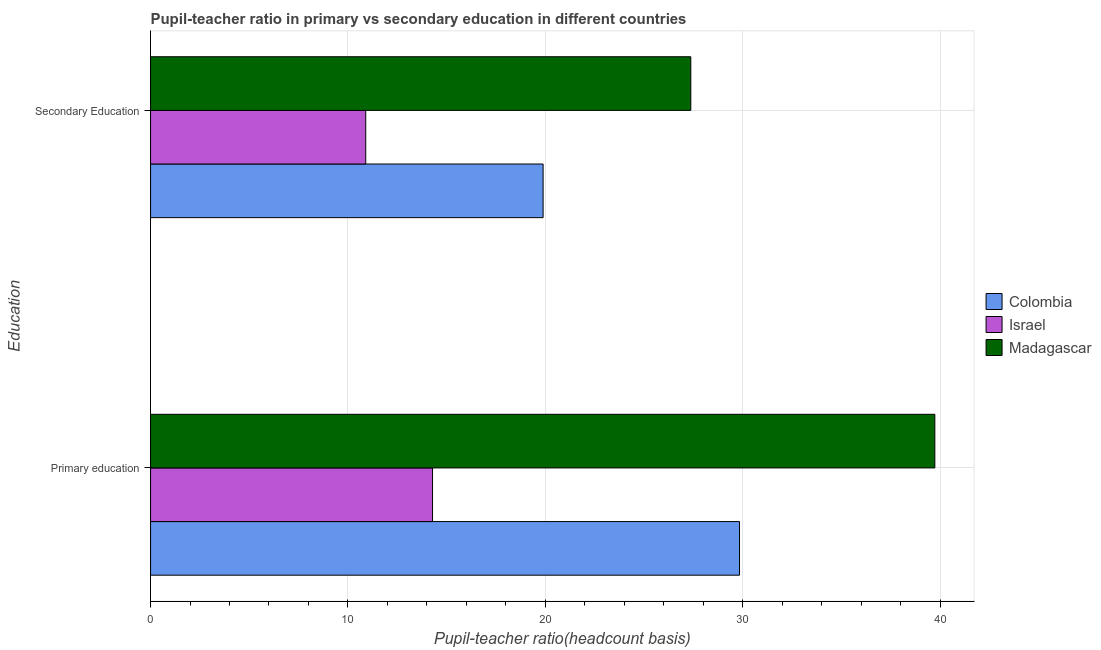How many groups of bars are there?
Your response must be concise. 2. Are the number of bars per tick equal to the number of legend labels?
Ensure brevity in your answer.  Yes. Are the number of bars on each tick of the Y-axis equal?
Keep it short and to the point. Yes. How many bars are there on the 2nd tick from the top?
Keep it short and to the point. 3. How many bars are there on the 1st tick from the bottom?
Offer a very short reply. 3. What is the label of the 1st group of bars from the top?
Provide a succinct answer. Secondary Education. What is the pupil-teacher ratio in primary education in Israel?
Provide a short and direct response. 14.29. Across all countries, what is the maximum pupil-teacher ratio in primary education?
Your response must be concise. 39.74. Across all countries, what is the minimum pupil-teacher ratio in primary education?
Keep it short and to the point. 14.29. In which country was the pupil-teacher ratio in primary education maximum?
Your response must be concise. Madagascar. In which country was the pupil-teacher ratio in primary education minimum?
Offer a terse response. Israel. What is the total pupil teacher ratio on secondary education in the graph?
Make the answer very short. 58.16. What is the difference between the pupil teacher ratio on secondary education in Madagascar and that in Colombia?
Offer a terse response. 7.48. What is the difference between the pupil-teacher ratio in primary education in Colombia and the pupil teacher ratio on secondary education in Madagascar?
Ensure brevity in your answer.  2.47. What is the average pupil-teacher ratio in primary education per country?
Provide a succinct answer. 27.95. What is the difference between the pupil-teacher ratio in primary education and pupil teacher ratio on secondary education in Israel?
Give a very brief answer. 3.38. In how many countries, is the pupil-teacher ratio in primary education greater than 16 ?
Provide a succinct answer. 2. What is the ratio of the pupil-teacher ratio in primary education in Colombia to that in Israel?
Offer a very short reply. 2.09. Is the pupil teacher ratio on secondary education in Israel less than that in Colombia?
Keep it short and to the point. Yes. In how many countries, is the pupil-teacher ratio in primary education greater than the average pupil-teacher ratio in primary education taken over all countries?
Give a very brief answer. 2. What does the 1st bar from the top in Secondary Education represents?
Make the answer very short. Madagascar. Are all the bars in the graph horizontal?
Provide a short and direct response. Yes. How many countries are there in the graph?
Offer a very short reply. 3. What is the difference between two consecutive major ticks on the X-axis?
Offer a very short reply. 10. Does the graph contain grids?
Ensure brevity in your answer.  Yes. How many legend labels are there?
Make the answer very short. 3. What is the title of the graph?
Offer a very short reply. Pupil-teacher ratio in primary vs secondary education in different countries. What is the label or title of the X-axis?
Offer a terse response. Pupil-teacher ratio(headcount basis). What is the label or title of the Y-axis?
Give a very brief answer. Education. What is the Pupil-teacher ratio(headcount basis) in Colombia in Primary education?
Offer a very short reply. 29.84. What is the Pupil-teacher ratio(headcount basis) of Israel in Primary education?
Your answer should be compact. 14.29. What is the Pupil-teacher ratio(headcount basis) of Madagascar in Primary education?
Keep it short and to the point. 39.74. What is the Pupil-teacher ratio(headcount basis) in Colombia in Secondary Education?
Provide a succinct answer. 19.89. What is the Pupil-teacher ratio(headcount basis) in Israel in Secondary Education?
Offer a very short reply. 10.9. What is the Pupil-teacher ratio(headcount basis) in Madagascar in Secondary Education?
Your answer should be compact. 27.37. Across all Education, what is the maximum Pupil-teacher ratio(headcount basis) of Colombia?
Your response must be concise. 29.84. Across all Education, what is the maximum Pupil-teacher ratio(headcount basis) of Israel?
Give a very brief answer. 14.29. Across all Education, what is the maximum Pupil-teacher ratio(headcount basis) in Madagascar?
Your response must be concise. 39.74. Across all Education, what is the minimum Pupil-teacher ratio(headcount basis) in Colombia?
Make the answer very short. 19.89. Across all Education, what is the minimum Pupil-teacher ratio(headcount basis) in Israel?
Give a very brief answer. 10.9. Across all Education, what is the minimum Pupil-teacher ratio(headcount basis) of Madagascar?
Your answer should be compact. 27.37. What is the total Pupil-teacher ratio(headcount basis) in Colombia in the graph?
Give a very brief answer. 49.73. What is the total Pupil-teacher ratio(headcount basis) in Israel in the graph?
Keep it short and to the point. 25.19. What is the total Pupil-teacher ratio(headcount basis) in Madagascar in the graph?
Offer a terse response. 67.11. What is the difference between the Pupil-teacher ratio(headcount basis) in Colombia in Primary education and that in Secondary Education?
Ensure brevity in your answer.  9.95. What is the difference between the Pupil-teacher ratio(headcount basis) in Israel in Primary education and that in Secondary Education?
Offer a terse response. 3.38. What is the difference between the Pupil-teacher ratio(headcount basis) in Madagascar in Primary education and that in Secondary Education?
Offer a terse response. 12.37. What is the difference between the Pupil-teacher ratio(headcount basis) in Colombia in Primary education and the Pupil-teacher ratio(headcount basis) in Israel in Secondary Education?
Your response must be concise. 18.94. What is the difference between the Pupil-teacher ratio(headcount basis) of Colombia in Primary education and the Pupil-teacher ratio(headcount basis) of Madagascar in Secondary Education?
Offer a terse response. 2.47. What is the difference between the Pupil-teacher ratio(headcount basis) of Israel in Primary education and the Pupil-teacher ratio(headcount basis) of Madagascar in Secondary Education?
Make the answer very short. -13.09. What is the average Pupil-teacher ratio(headcount basis) in Colombia per Education?
Offer a very short reply. 24.86. What is the average Pupil-teacher ratio(headcount basis) in Israel per Education?
Give a very brief answer. 12.59. What is the average Pupil-teacher ratio(headcount basis) in Madagascar per Education?
Ensure brevity in your answer.  33.55. What is the difference between the Pupil-teacher ratio(headcount basis) of Colombia and Pupil-teacher ratio(headcount basis) of Israel in Primary education?
Your answer should be compact. 15.55. What is the difference between the Pupil-teacher ratio(headcount basis) in Colombia and Pupil-teacher ratio(headcount basis) in Madagascar in Primary education?
Your answer should be very brief. -9.9. What is the difference between the Pupil-teacher ratio(headcount basis) in Israel and Pupil-teacher ratio(headcount basis) in Madagascar in Primary education?
Your answer should be compact. -25.45. What is the difference between the Pupil-teacher ratio(headcount basis) of Colombia and Pupil-teacher ratio(headcount basis) of Israel in Secondary Education?
Give a very brief answer. 8.99. What is the difference between the Pupil-teacher ratio(headcount basis) of Colombia and Pupil-teacher ratio(headcount basis) of Madagascar in Secondary Education?
Make the answer very short. -7.48. What is the difference between the Pupil-teacher ratio(headcount basis) of Israel and Pupil-teacher ratio(headcount basis) of Madagascar in Secondary Education?
Give a very brief answer. -16.47. What is the ratio of the Pupil-teacher ratio(headcount basis) of Colombia in Primary education to that in Secondary Education?
Keep it short and to the point. 1.5. What is the ratio of the Pupil-teacher ratio(headcount basis) of Israel in Primary education to that in Secondary Education?
Make the answer very short. 1.31. What is the ratio of the Pupil-teacher ratio(headcount basis) of Madagascar in Primary education to that in Secondary Education?
Keep it short and to the point. 1.45. What is the difference between the highest and the second highest Pupil-teacher ratio(headcount basis) in Colombia?
Give a very brief answer. 9.95. What is the difference between the highest and the second highest Pupil-teacher ratio(headcount basis) of Israel?
Give a very brief answer. 3.38. What is the difference between the highest and the second highest Pupil-teacher ratio(headcount basis) in Madagascar?
Offer a very short reply. 12.37. What is the difference between the highest and the lowest Pupil-teacher ratio(headcount basis) of Colombia?
Your answer should be very brief. 9.95. What is the difference between the highest and the lowest Pupil-teacher ratio(headcount basis) in Israel?
Provide a succinct answer. 3.38. What is the difference between the highest and the lowest Pupil-teacher ratio(headcount basis) in Madagascar?
Make the answer very short. 12.37. 